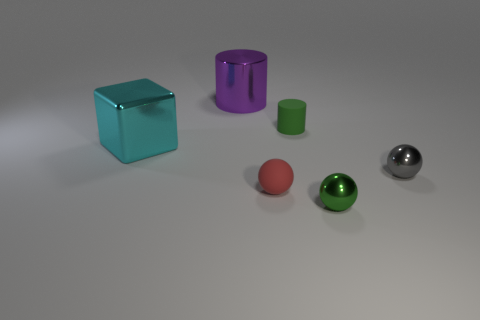Subtract 1 spheres. How many spheres are left? 2 Add 2 tiny gray shiny balls. How many objects exist? 8 Subtract all cubes. How many objects are left? 5 Subtract all small red shiny cylinders. Subtract all small matte spheres. How many objects are left? 5 Add 6 purple metallic cylinders. How many purple metallic cylinders are left? 7 Add 3 purple cylinders. How many purple cylinders exist? 4 Subtract 0 cyan cylinders. How many objects are left? 6 